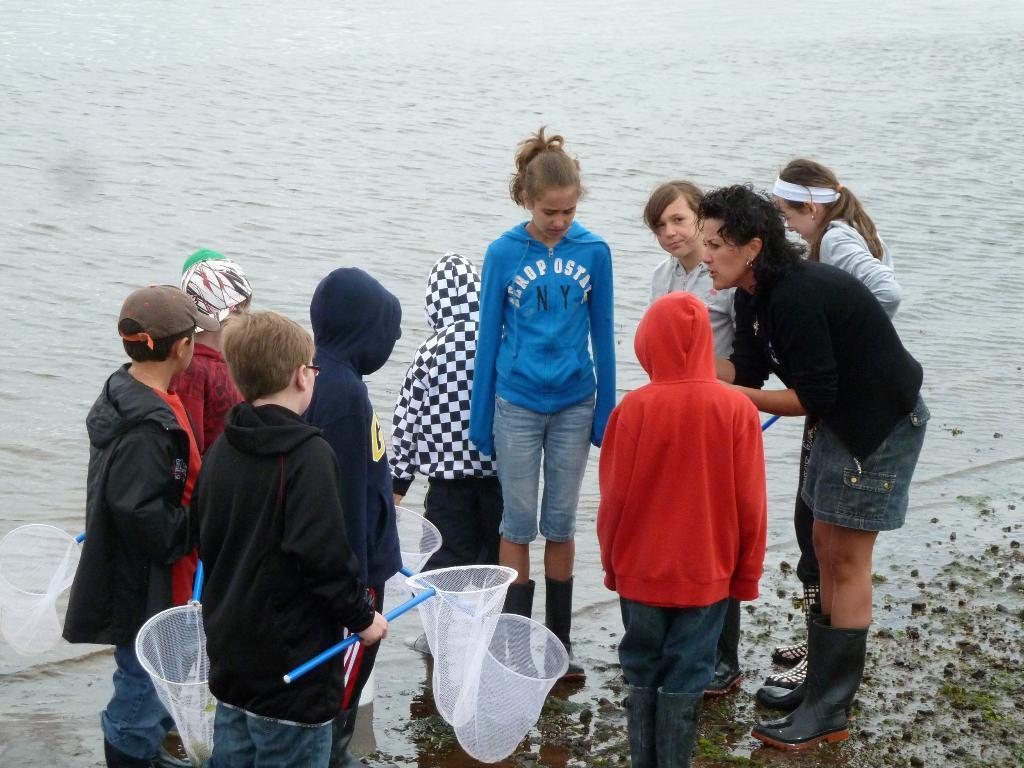Could you give a brief overview of what you see in this image? This image consists of many children and a woman, standing near the water. They are holding the nets in their hands. In the background, there is water. 